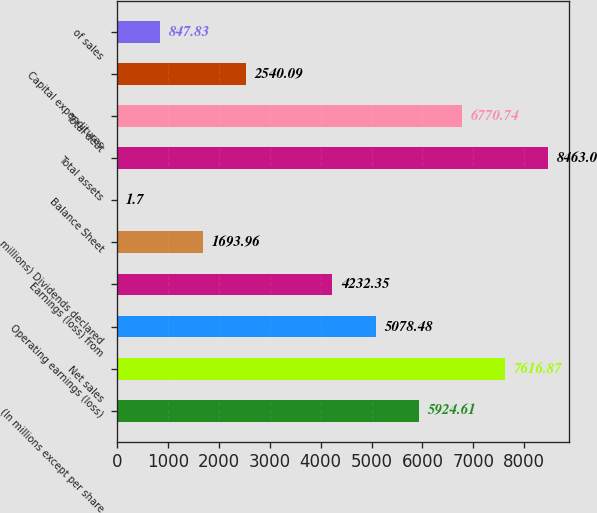Convert chart. <chart><loc_0><loc_0><loc_500><loc_500><bar_chart><fcel>(In millions except per share<fcel>Net sales<fcel>Operating earnings (loss)<fcel>Earnings (loss) from<fcel>millions) Dividends declared<fcel>Balance Sheet<fcel>Total assets<fcel>Total debt<fcel>Capital expenditures<fcel>of sales<nl><fcel>5924.61<fcel>7616.87<fcel>5078.48<fcel>4232.35<fcel>1693.96<fcel>1.7<fcel>8463<fcel>6770.74<fcel>2540.09<fcel>847.83<nl></chart> 